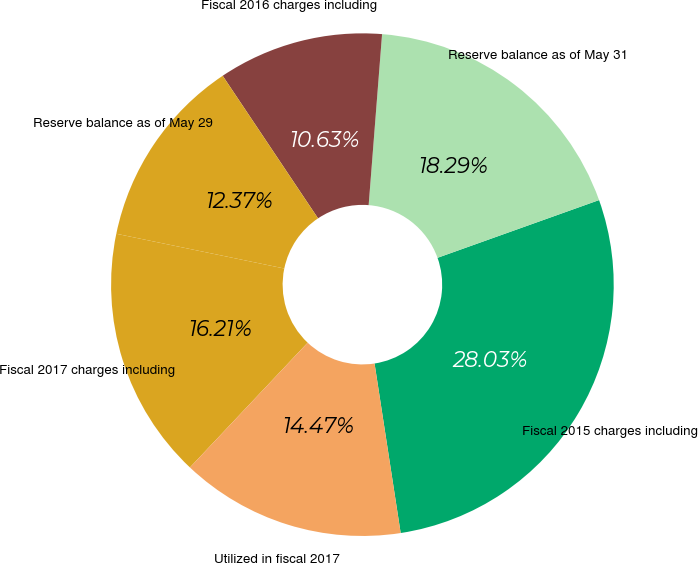<chart> <loc_0><loc_0><loc_500><loc_500><pie_chart><fcel>Fiscal 2015 charges including<fcel>Reserve balance as of May 31<fcel>Fiscal 2016 charges including<fcel>Reserve balance as of May 29<fcel>Fiscal 2017 charges including<fcel>Utilized in fiscal 2017<nl><fcel>28.03%<fcel>18.29%<fcel>10.63%<fcel>12.37%<fcel>16.21%<fcel>14.47%<nl></chart> 